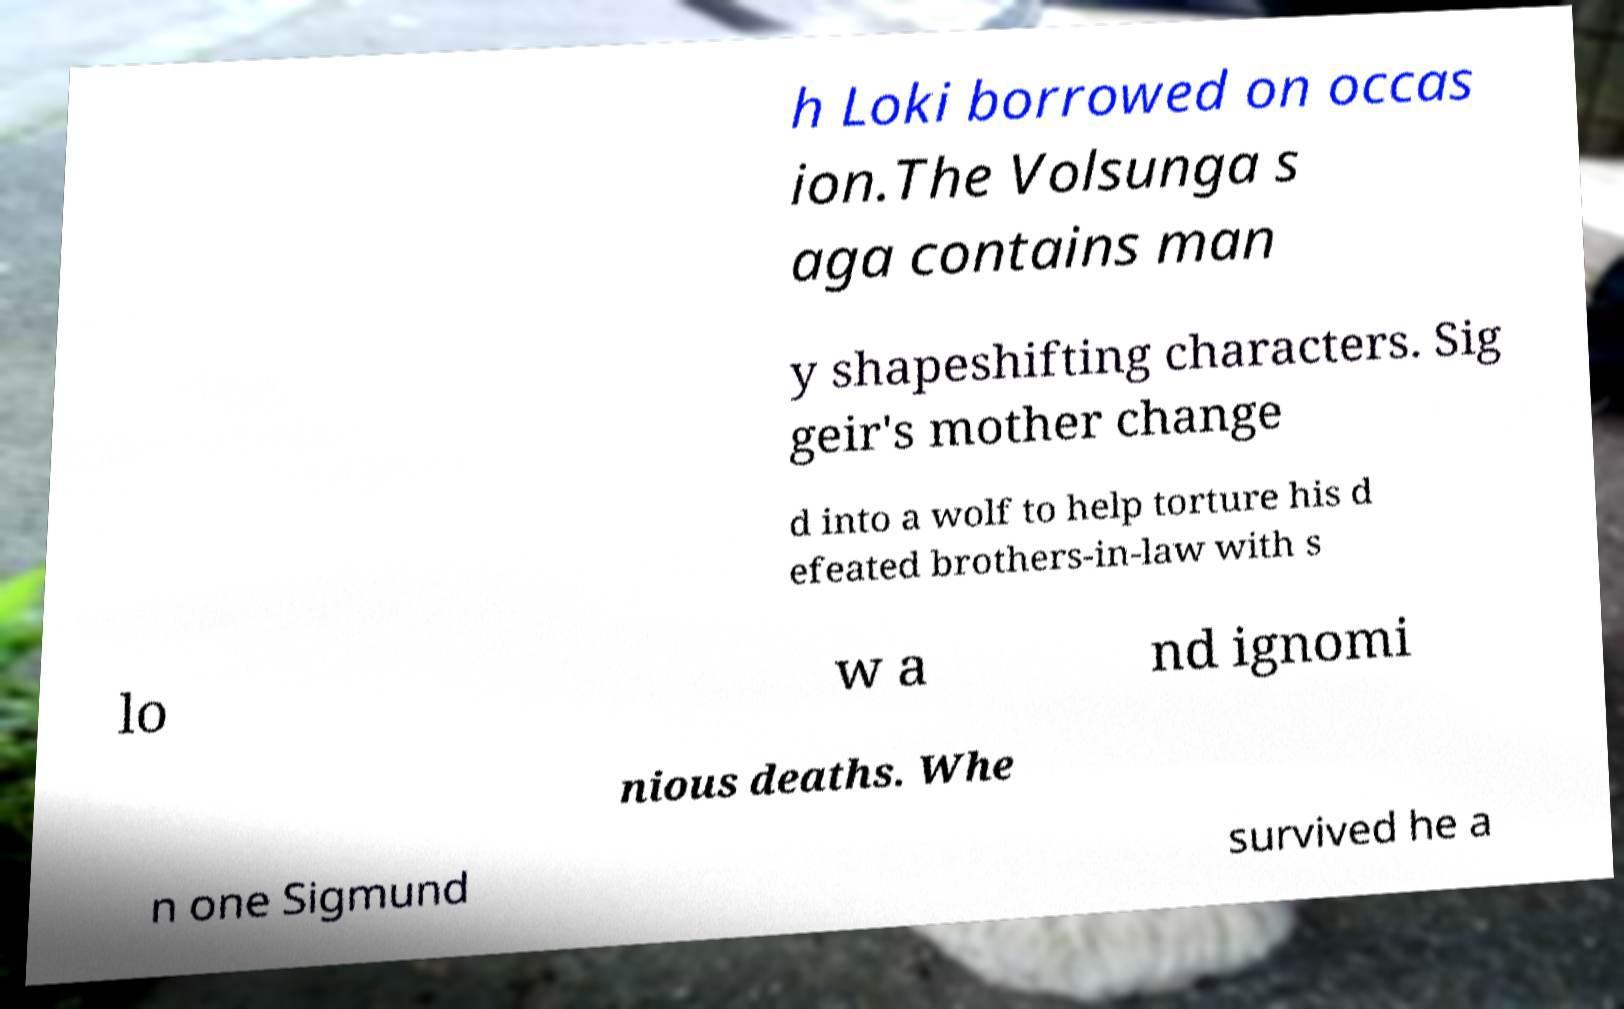Could you assist in decoding the text presented in this image and type it out clearly? h Loki borrowed on occas ion.The Volsunga s aga contains man y shapeshifting characters. Sig geir's mother change d into a wolf to help torture his d efeated brothers-in-law with s lo w a nd ignomi nious deaths. Whe n one Sigmund survived he a 